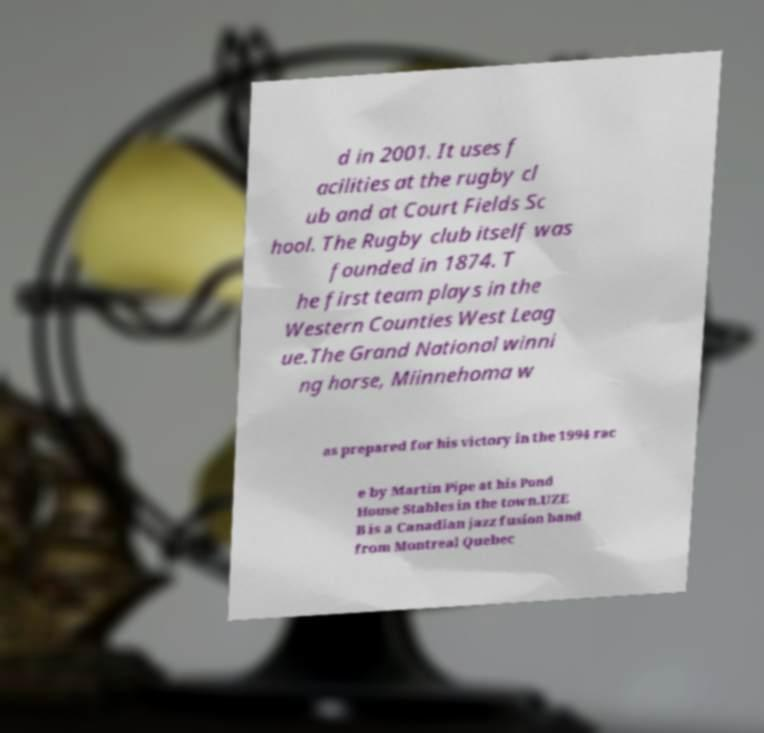Please identify and transcribe the text found in this image. d in 2001. It uses f acilities at the rugby cl ub and at Court Fields Sc hool. The Rugby club itself was founded in 1874. T he first team plays in the Western Counties West Leag ue.The Grand National winni ng horse, Miinnehoma w as prepared for his victory in the 1994 rac e by Martin Pipe at his Pond House Stables in the town.UZE B is a Canadian jazz fusion band from Montreal Quebec 